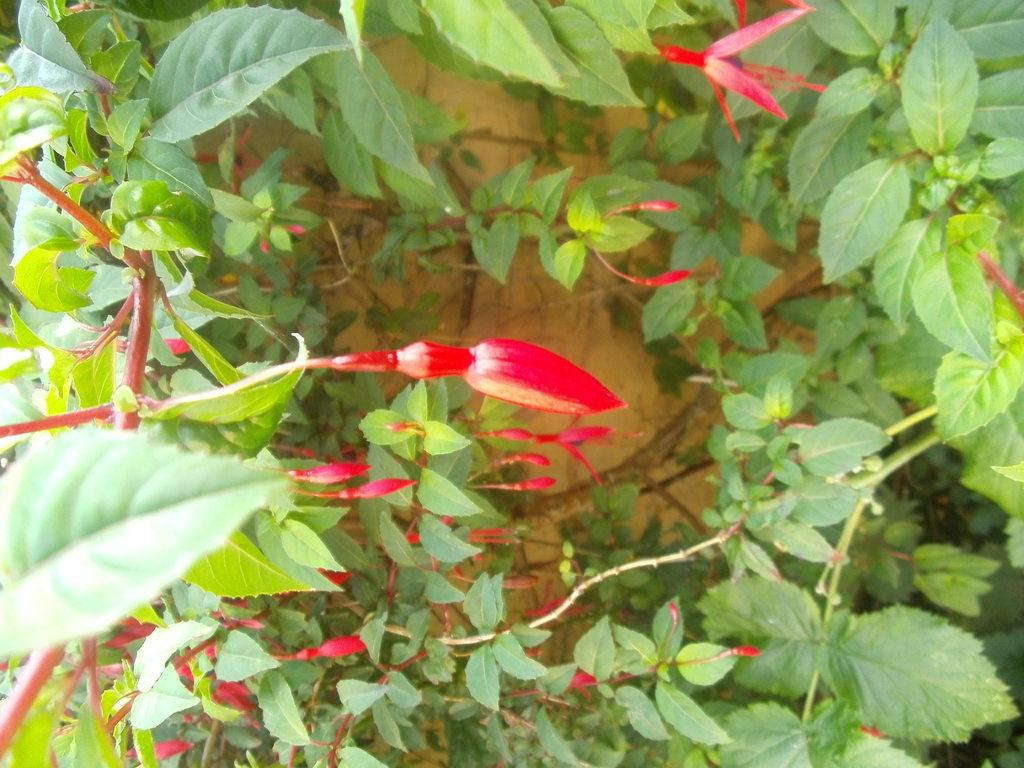What color are the buds on the plants in the image? The buds on the plants are red-colored. What can be seen at the bottom of the image? There is sand at the bottom of the image. What type of leaves are surrounding the buds? There are green leaves surrounding the buds. What type of root can be seen growing from the hammer in the image? There is no hammer present in the image, so there is no root growing from it. 